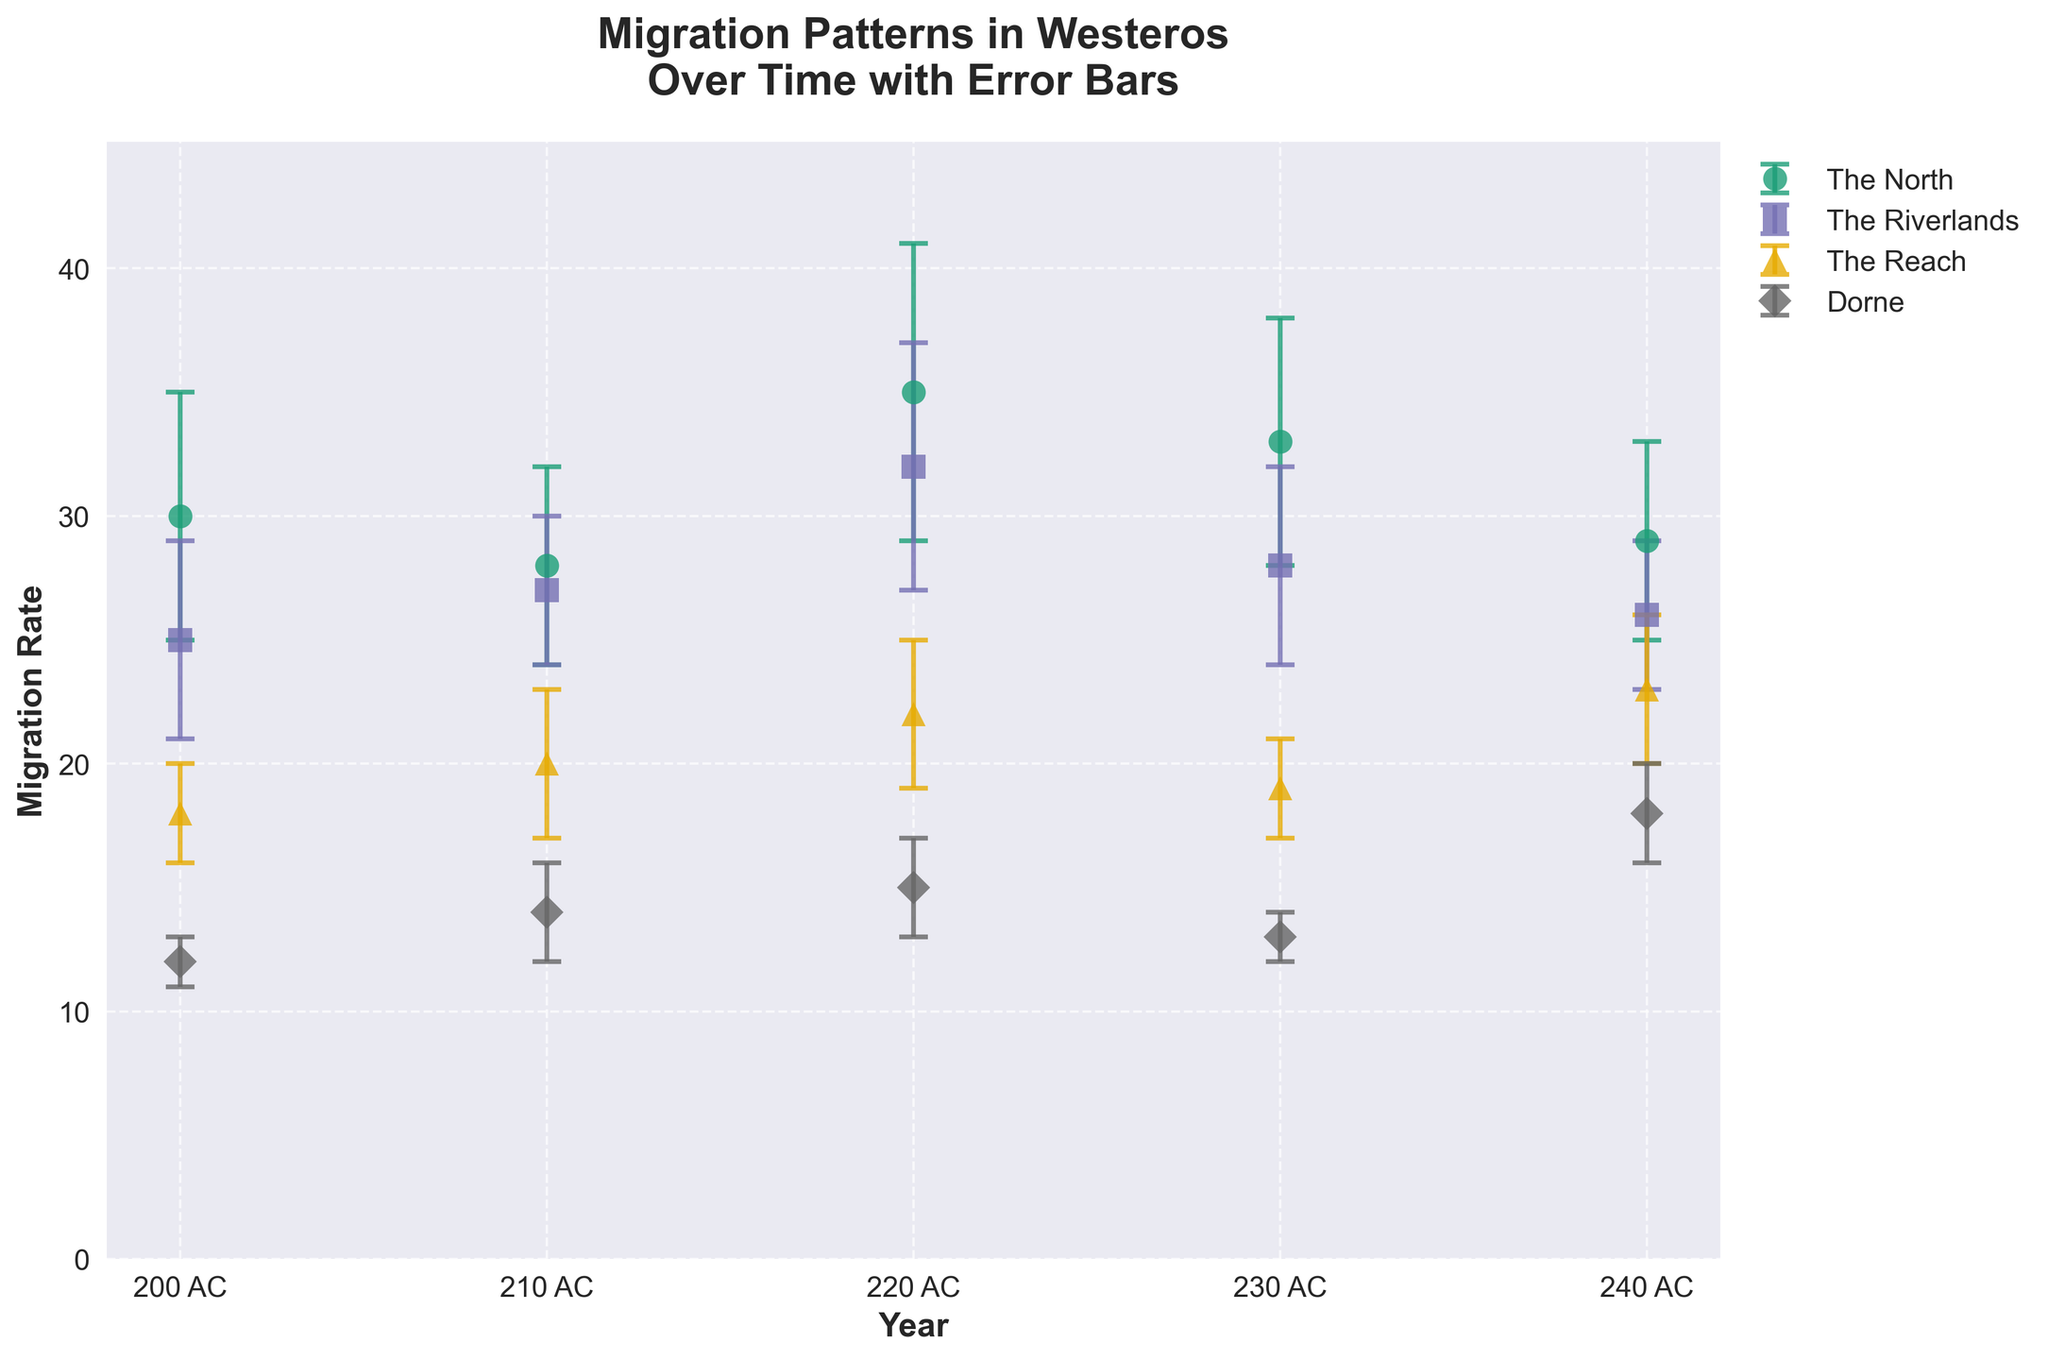Which region has the highest migration rate in the year 220 AC? Look at the year 220 AC on the x-axis and compare the migration rate along the y-axis for all regions. The North has the highest migration rate of 35 at this point.
Answer: The North What is the average migration rate of The Reach from 200 AC to 240 AC? Identify the migration rates for The Reach across the given years: [18, 20, 22, 19, 23]. Sum them up: 18 + 20 + 22 + 19 + 23 = 102, then divide by the number of years (5): 102 / 5 = 20.4.
Answer: 20.4 Which year shows the lowest migration rate in Dorne? Identify the migration rates for Dorne: [12, 14, 15, 13, 18]. The lowest value is 12 in the year 200 AC.
Answer: 200 AC How does the migration rate trend for The North compare to The Riverlands from 200 AC to 240 AC? Examine the lines plotted for The North and The Riverlands. The North typically has higher migration rates, but both regions show fluctuating trends. The North's migration rate peaks in 220 AC and slightly falls, while The Riverlands peaks at the same year but does not surpass The North.
Answer: The North generally higher, both fluctuate Between 230 AC and 240 AC, which region shows the greatest increase in migration rate? Calculate the difference in migration rates for each region between 230 AC and 240 AC. The North: 33–29=4, The Riverlands: 28–26=2, The Reach: 19–23=4, Dorne: 13–18=5. Dorne shows the greatest increase of 5.
Answer: Dorne What is the overall trend for Dorne's migration rate from 200 AC to 240 AC? Observe the plotted line for Dorne from 200 AC to 240 AC. The trend shows an initial increase, a slight dip, then a significant rise ending with a peak at 18 in 240 AC.
Answer: Increasing with fluctuation Which region shows the most consistent migration rates, based on error bars? Compare the lengths of error bars for all regions. The Reach has relatively shorter and more consistent error bars over the years compared to other regions with more variation.
Answer: The Reach What is the migration rate difference in The North between 220 AC and 230 AC? Identify the migration rates for The North in 220 AC and 230 AC, which are 35 and 33, respectively. The difference is 35–33=2.
Answer: 2 How do the error bars in 200 AC for all regions compare? Observe the error bars for each region in the year 200 AC. The North has the longest error bar (5), followed by The Riverlands and The Reach (both shorter than The North), and Dorne with the shortest error bar (1).
Answer: The North longest, Dorne shortest 